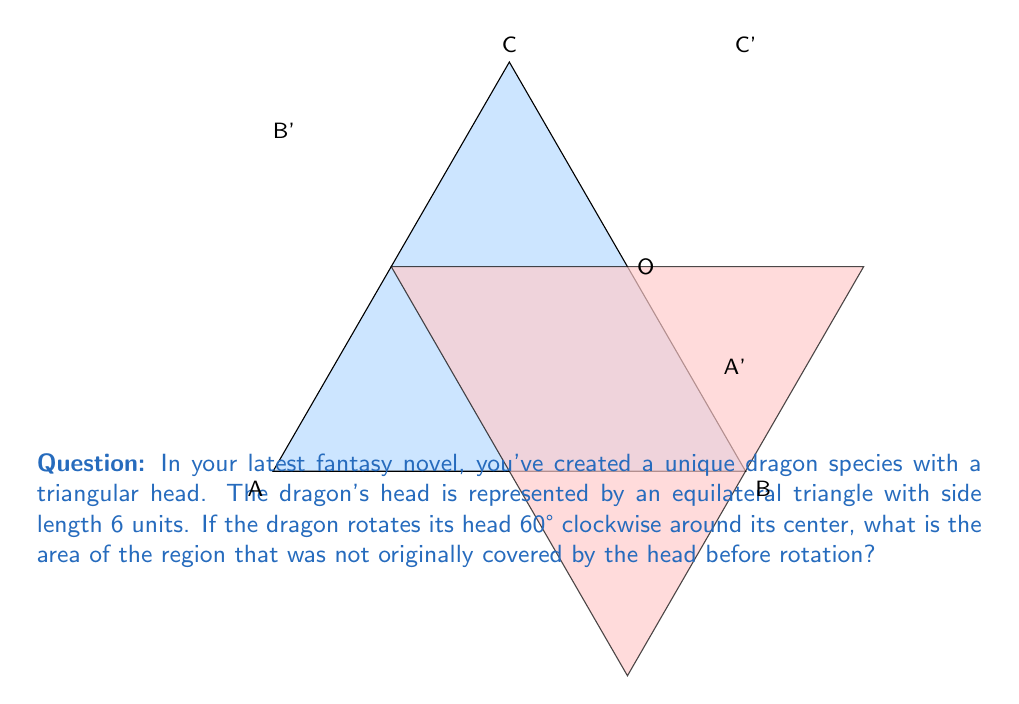Help me with this question. Let's approach this step-by-step:

1) First, we need to calculate the area of the equilateral triangle. The area of an equilateral triangle is given by:

   $$A = \frac{\sqrt{3}}{4}a^2$$

   where $a$ is the side length.

2) With $a = 6$, the area is:

   $$A = \frac{\sqrt{3}}{4}(6^2) = 9\sqrt{3}$$ square units

3) When the triangle rotates 60°, it forms a shape similar to a six-pointed star. The area we're looking for is the area of this star minus the area of the original triangle.

4) The star shape is actually made up of six equilateral triangles, each with side length 3 (half of the original side length).

5) The area of each small triangle is:

   $$A_{small} = \frac{\sqrt{3}}{4}(3^2) = \frac{9\sqrt{3}}{4}$$ square units

6) There are six of these small triangles, but only three of them are in the area we're looking for (the other three overlap with the original triangle). So the area we're looking for is:

   $$A_{new} = 3 \cdot \frac{9\sqrt{3}}{4} = \frac{27\sqrt{3}}{4}$$ square units

7) Therefore, the area that was not originally covered is:

   $$A_{final} = \frac{27\sqrt{3}}{4} - 9\sqrt{3} = \frac{27\sqrt{3}}{4} - \frac{36\sqrt{3}}{4} = -\frac{9\sqrt{3}}{4}$$

8) Since area can't be negative, we take the absolute value:

   $$A_{final} = \frac{9\sqrt{3}}{4}$$ square units
Answer: $\frac{9\sqrt{3}}{4}$ square units 